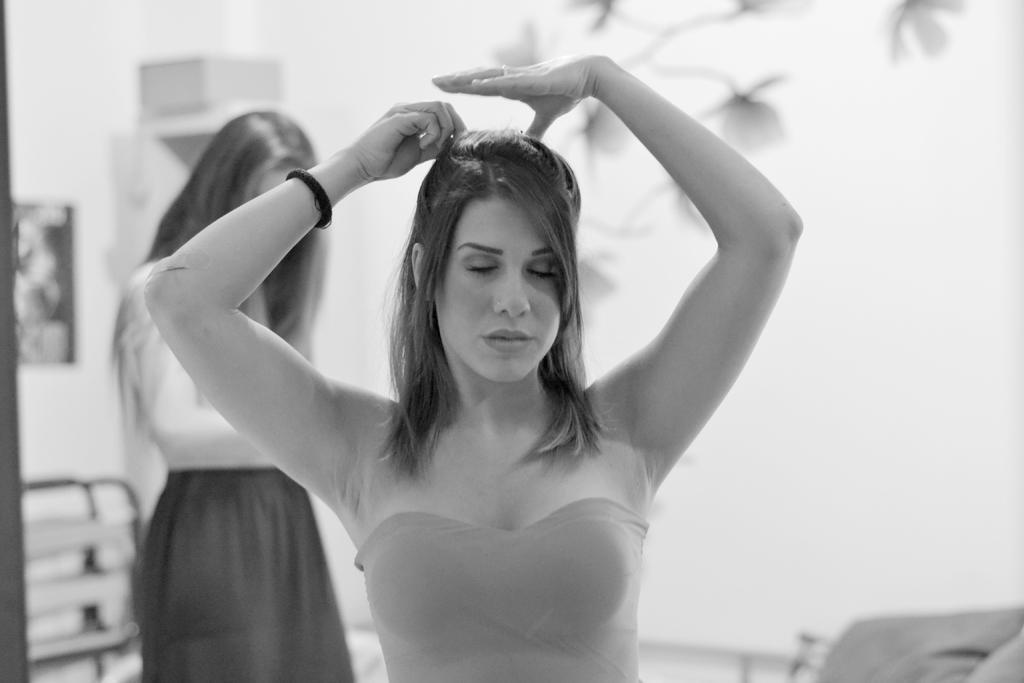In one or two sentences, can you explain what this image depicts? In the center of this picture we can see the two women seems to be standing. In the background we can see many other objects. 